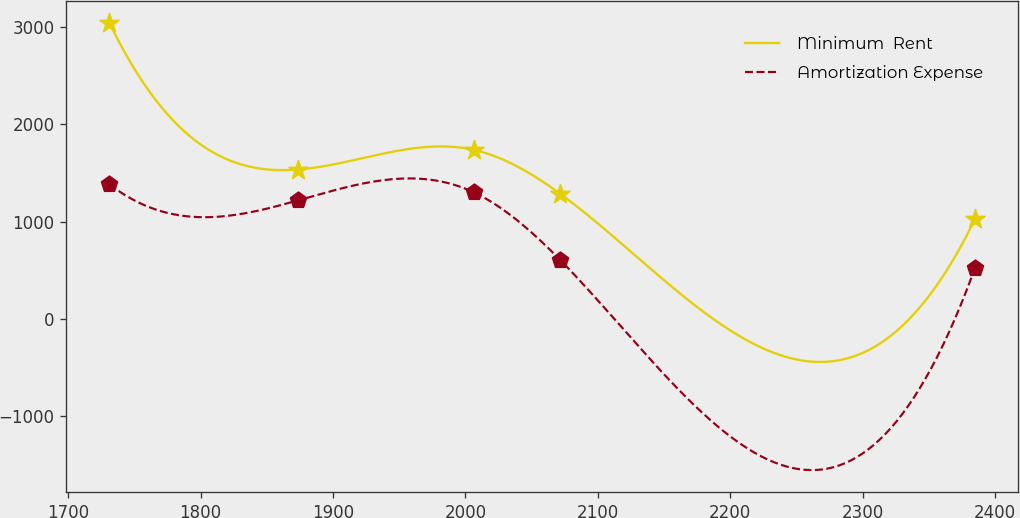Convert chart. <chart><loc_0><loc_0><loc_500><loc_500><line_chart><ecel><fcel>Minimum  Rent<fcel>Amortization Expense<nl><fcel>1731.17<fcel>3046.45<fcel>1383.95<nl><fcel>1873.31<fcel>1535.45<fcel>1216.83<nl><fcel>2006.42<fcel>1738<fcel>1300.39<nl><fcel>2071.77<fcel>1283.85<fcel>601.32<nl><fcel>2384.65<fcel>1020.99<fcel>517.76<nl></chart> 